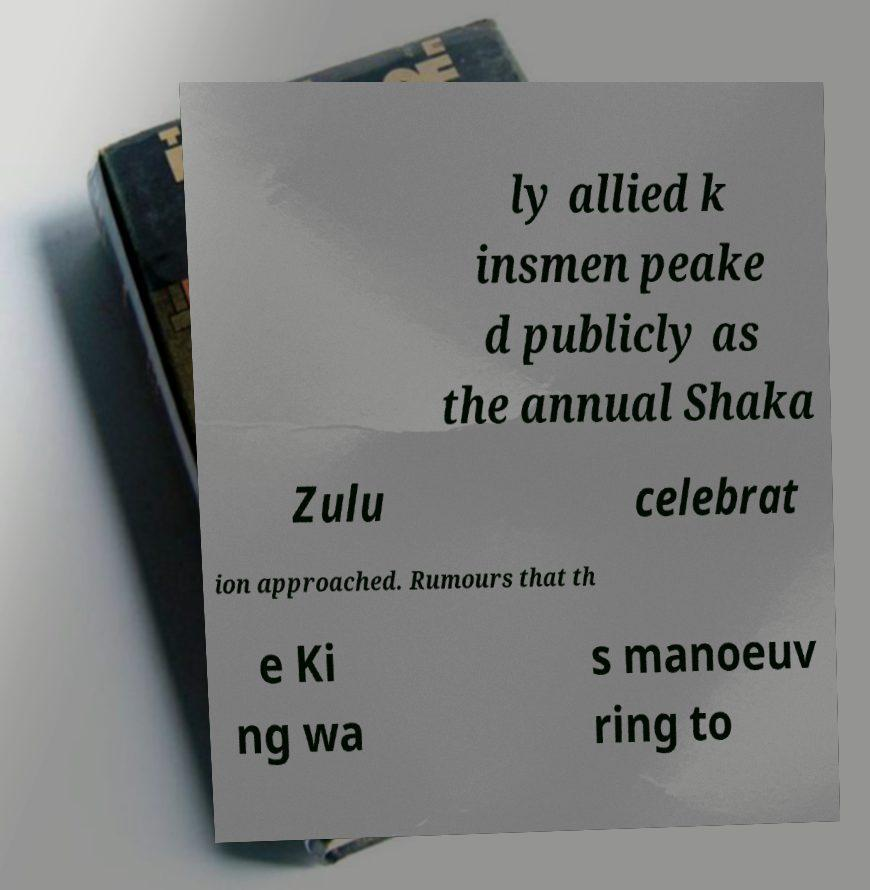I need the written content from this picture converted into text. Can you do that? ly allied k insmen peake d publicly as the annual Shaka Zulu celebrat ion approached. Rumours that th e Ki ng wa s manoeuv ring to 